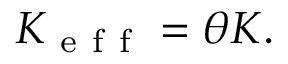<formula> <loc_0><loc_0><loc_500><loc_500>K _ { e f f } = \theta K .</formula> 